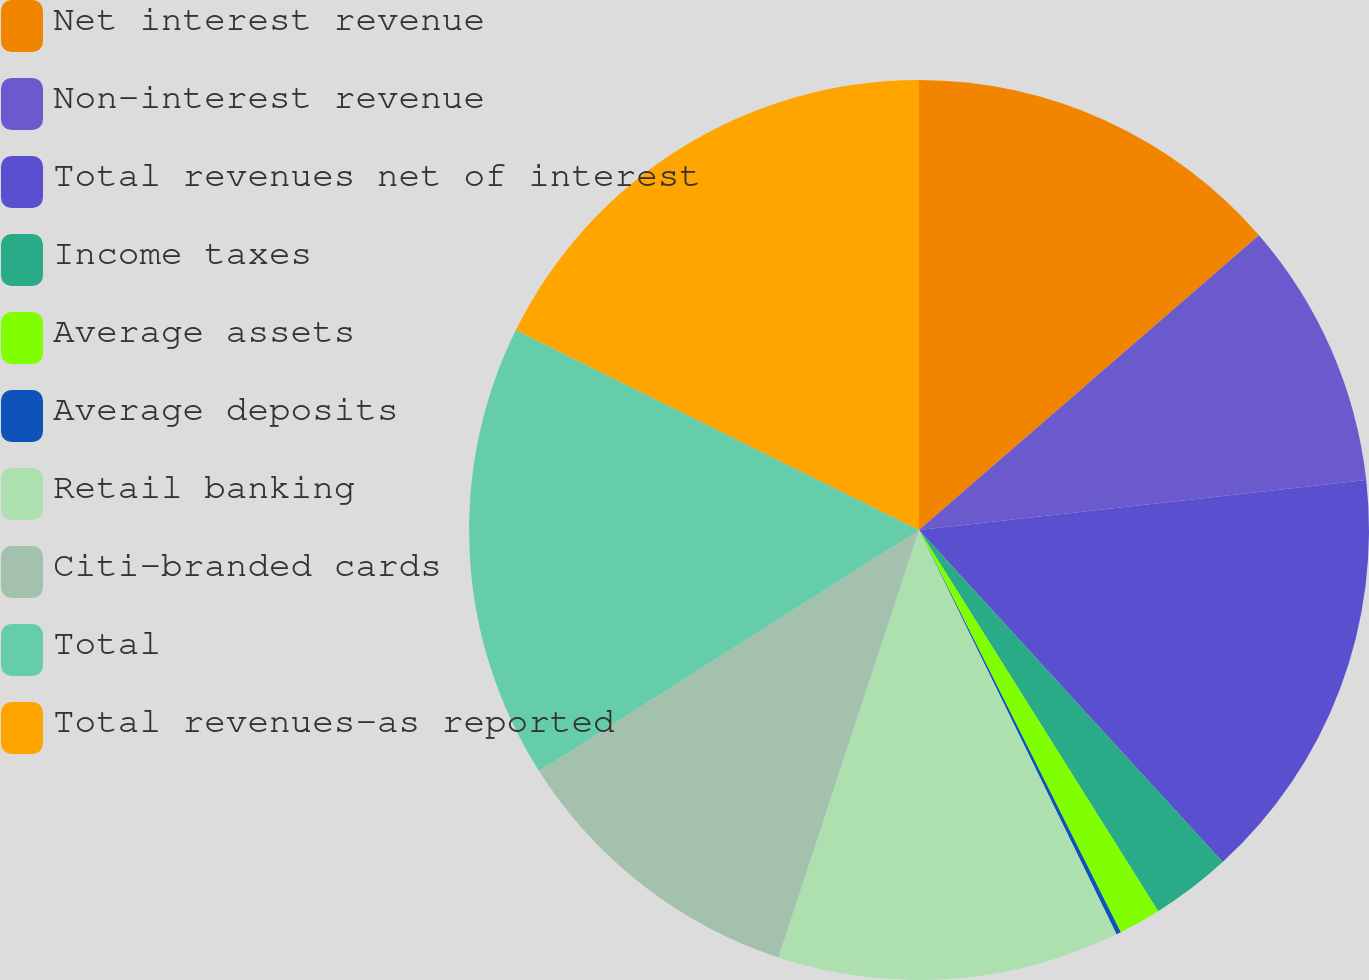Convert chart to OTSL. <chart><loc_0><loc_0><loc_500><loc_500><pie_chart><fcel>Net interest revenue<fcel>Non-interest revenue<fcel>Total revenues net of interest<fcel>Income taxes<fcel>Average assets<fcel>Average deposits<fcel>Retail banking<fcel>Citi-branded cards<fcel>Total<fcel>Total revenues-as reported<nl><fcel>13.63%<fcel>9.6%<fcel>14.98%<fcel>2.87%<fcel>1.52%<fcel>0.17%<fcel>12.29%<fcel>10.94%<fcel>16.33%<fcel>17.67%<nl></chart> 